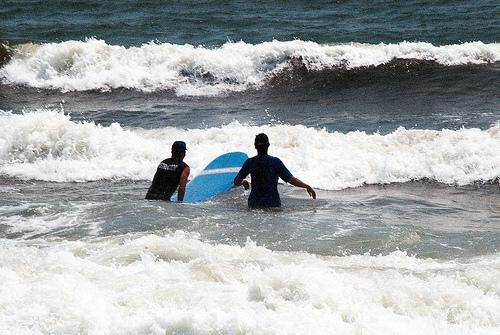Question: what are the two people doing?
Choices:
A. Surfing.
B. Sitting in chairs.
C. Skateboarding.
D. Holding hands.
Answer with the letter. Answer: A Question: why are the people wet?
Choices:
A. It's raining.
B. They are in the pool.
C. There in water.
D. The water hose is running.
Answer with the letter. Answer: C Question: how many waves are there?
Choices:
A. Two.
B. One.
C. Three.
D. None.
Answer with the letter. Answer: C Question: where was this picture taken?
Choices:
A. In the wilderness.
B. In the house.
C. The beach.
D. At the game.
Answer with the letter. Answer: C Question: when was this photo taken?
Choices:
A. Daytime.
B. In the evening.
C. At the end of the game.
D. In the morning.
Answer with the letter. Answer: A 